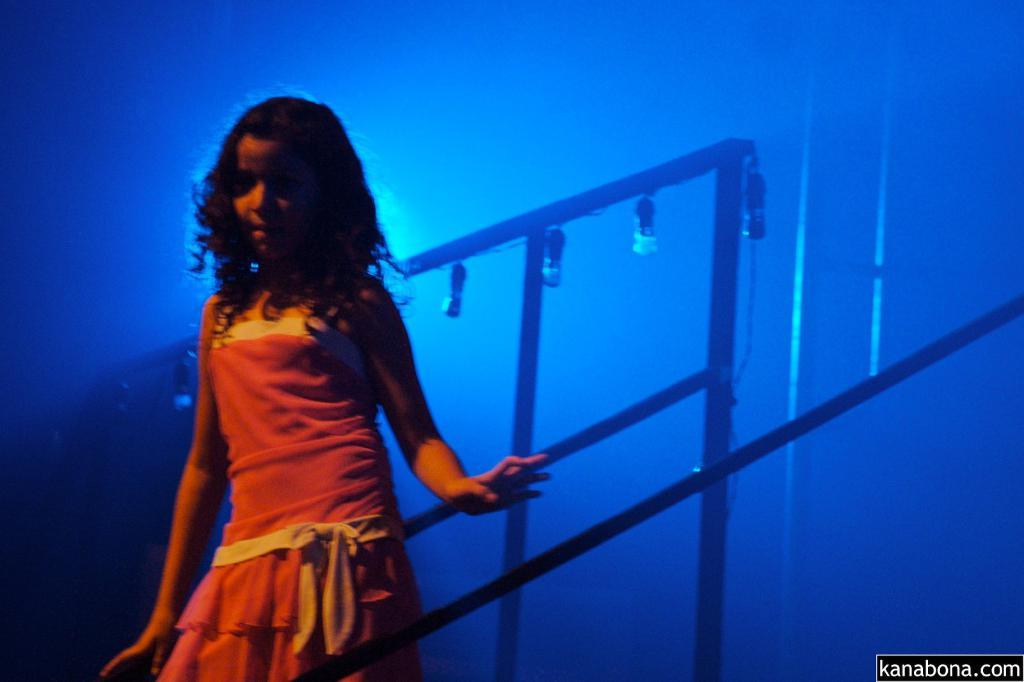What is located on the left side of the image? There is a girl standing on the left side of the image. What can be seen in the background of the image? There are lights and rods in the background of the image. What type of shirt is the girl wearing in the image? The provided facts do not mention the girl's shirt, so we cannot determine the type of shirt she is wearing from the image. 